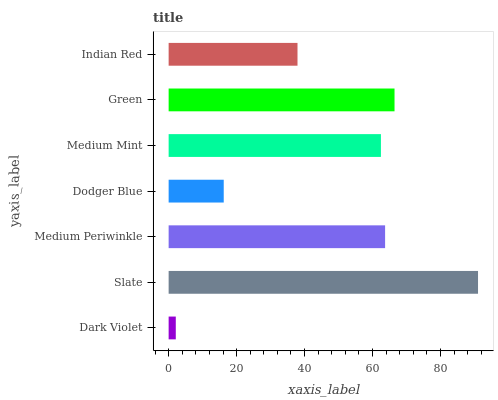Is Dark Violet the minimum?
Answer yes or no. Yes. Is Slate the maximum?
Answer yes or no. Yes. Is Medium Periwinkle the minimum?
Answer yes or no. No. Is Medium Periwinkle the maximum?
Answer yes or no. No. Is Slate greater than Medium Periwinkle?
Answer yes or no. Yes. Is Medium Periwinkle less than Slate?
Answer yes or no. Yes. Is Medium Periwinkle greater than Slate?
Answer yes or no. No. Is Slate less than Medium Periwinkle?
Answer yes or no. No. Is Medium Mint the high median?
Answer yes or no. Yes. Is Medium Mint the low median?
Answer yes or no. Yes. Is Medium Periwinkle the high median?
Answer yes or no. No. Is Dodger Blue the low median?
Answer yes or no. No. 